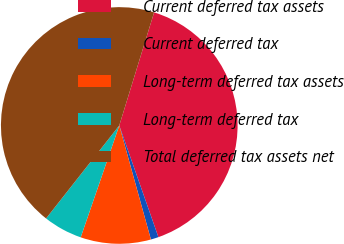<chart> <loc_0><loc_0><loc_500><loc_500><pie_chart><fcel>Current deferred tax assets<fcel>Current deferred tax<fcel>Long-term deferred tax assets<fcel>Long-term deferred tax<fcel>Total deferred tax assets net<nl><fcel>39.88%<fcel>1.06%<fcel>9.59%<fcel>5.33%<fcel>44.14%<nl></chart> 